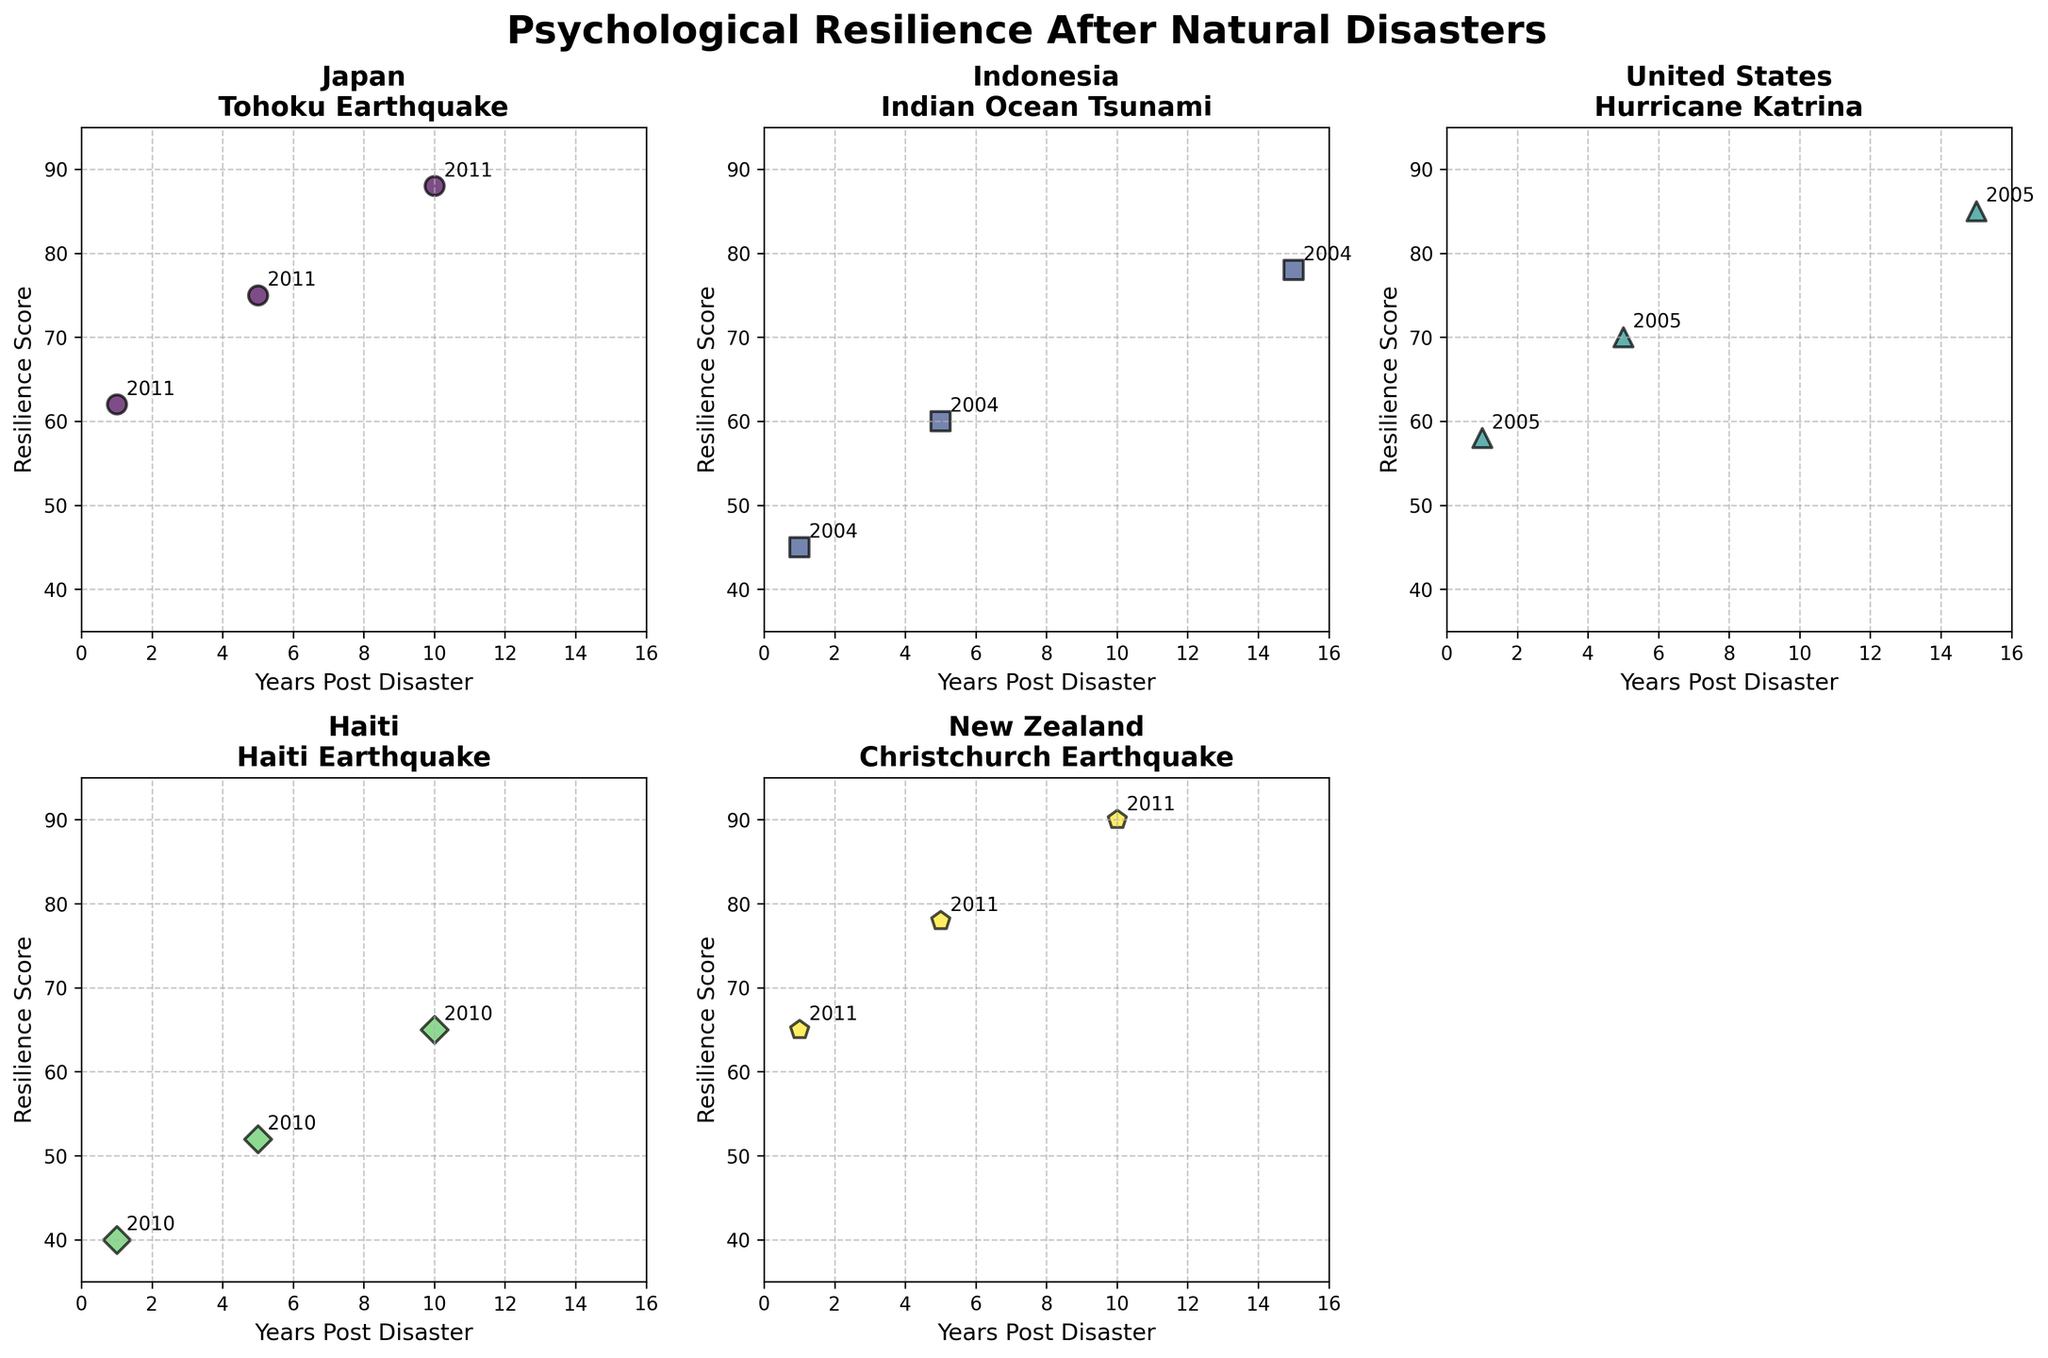What's the title of the figure? The title of the figure is prominently displayed at the top. It reads 'Psychological Resilience After Natural Disasters'.
Answer: Psychological Resilience After Natural Disasters Which country showed the greatest increase in Resilience Score over time? To determine the greatest increase, compare the final Resilience Score with the initial Resilience Score for each country. Japan increased from 62 to 88, Indonesia from 45 to 78, the United States from 58 to 85, Haiti from 40 to 65, and New Zealand from 65 to 90. New Zealand had the largest increase.
Answer: New Zealand What is the x-axis label in the Japan subplot? The x-axis label can be found at the bottom of the Japan subplot. It is labeled 'Years Post Disaster'.
Answer: Years Post Disaster Which country's resilience score was the lowest 5 years after the disaster? The resilience scores 5 years after the disaster are: Japan 75, Indonesia 60, the United States 70, Haiti 52, and New Zealand 78. Haiti has the lowest score.
Answer: Haiti What resilience score did the United States achieve 15 years after Hurricane Katrina? For the United States subplot, locate the data point at 15 years post-disaster. The resilience score at this point is 85.
Answer: 85 How does Haiti's resilience evolution compare to Indonesia's? Compare the resilience scores at 1, 5, and 10/15 years post-disaster for Haiti and Indonesia. Haiti's scores are 40, 52, and 65, while Indonesia's are 45, 60, and 78. Indonesia shows greater resilience at each corresponding year.
Answer: Indonesia shows greater resilience at each corresponding year What trend can be observed in resilience scores over time for all countries? All countries show an increasing trend in resilience scores over time. For instance, Japan's resilience scores rise from 62 to 88, indicating a recovery trend. This trend is similarly observed in other countries.
Answer: Increasing trend What disaster affected New Zealand in the data? The title of the subplot for New Zealand indicates the disaster it faced. It is labeled the 'Christchurch Earthquake'.
Answer: Christchurch Earthquake 